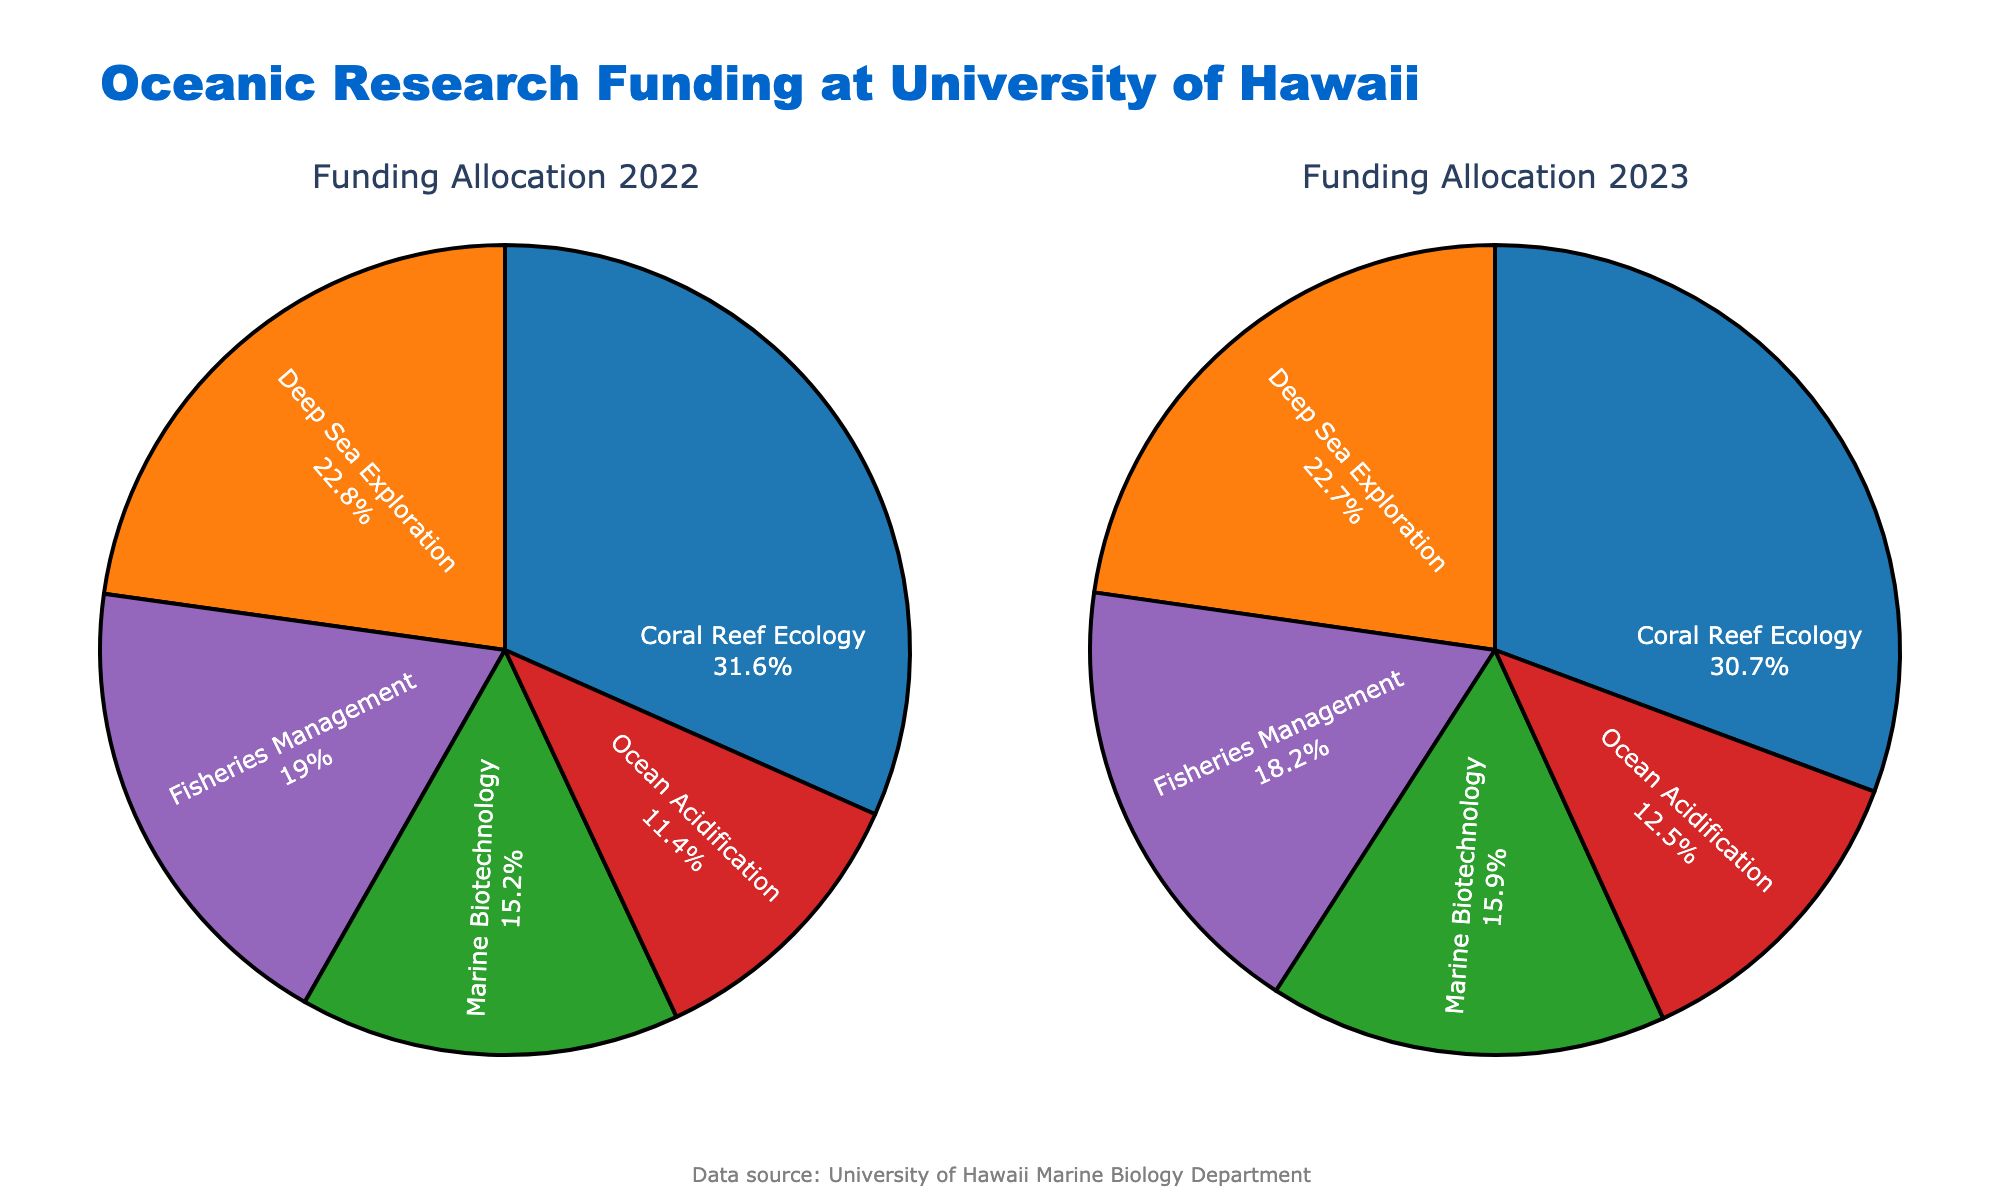What's the title of the figure? The title is located at the top of the figure. Look for a large, typically bold text that summarizes the content of the figure.
Answer: Oceanic Research Funding at University of Hawaii How many subplots are there in the figure? Identify the number of distinct pie charts within the figure. Each separate chart represents one subplot.
Answer: 2 Which research area received the highest funding in 2022? Observe the sections of the pie chart labeled by research areas and compare their sizes. The largest section represents the highest funding amount.
Answer: Coral Reef Ecology What is the total funding amount for Ocean Acidification over the two years? Sum the funding amounts for each year from the respective pie charts. In 2022, it’s $900,000 and in 2023, it’s $1,100,000. Therefore, $900,000 + $1,100,000 = $2,000,000.
Answer: $2,000,000 Which research area showed an increased funding allocation from 2022 to 2023? Compare the pie chart sections for each research area between 2022 and 2023. Look for an increase in the size of any section from 2022 to 2023.
Answer: Coral Reef Ecology In 2023, which research area had the smallest share of the funding allocation? Identify the pie chart section with the smallest percentage in the 2023 subplot, which indicates the research area with the smallest share.
Answer: Ocean Acidification What was the difference in funding for Deep Sea Exploration between 2022 and 2023? Subtract the 2022 funding amount from the 2023 funding amount for Deep Sea Exploration. $2,000,000 (2023) - $1,800,000 (2022) = $200,000.
Answer: $200,000 By how much did the funding for Marine Biotechnology increase from 2022 to 2023? Subtract the 2022 funding amount from the 2023 funding amount for Marine Biotechnology. $1,400,000 (2023) - $1,200,000 (2022) = $200,000.
Answer: $200,000 What percentage of the total funding in 2022 was allocated to Fisheries Management? Divide the funding amount for Fisheries Management by the total funding for all research areas in 2022, then multiply by 100. $(1,500,000 / 7,300,000) \times 100 ≈ 20.55\%$.
Answer: 20.55% 